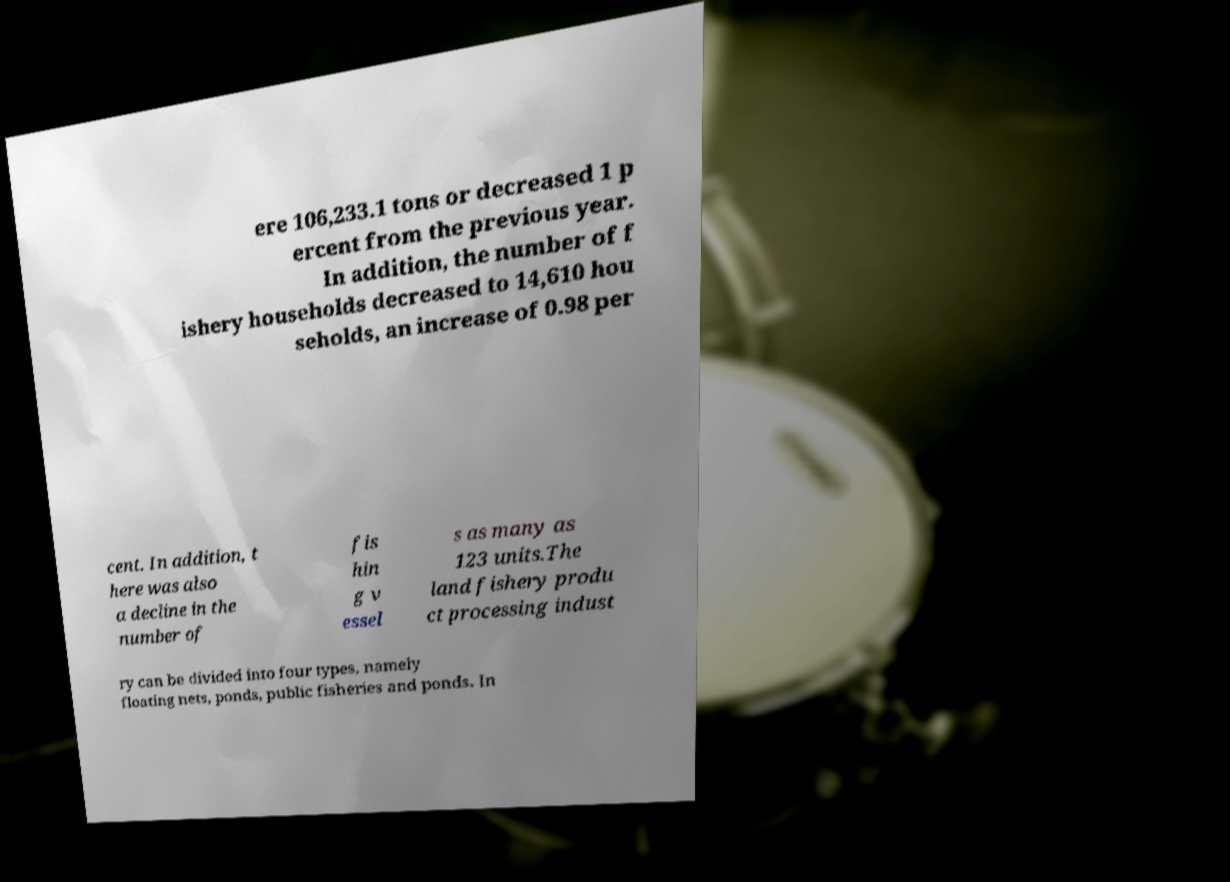I need the written content from this picture converted into text. Can you do that? ere 106,233.1 tons or decreased 1 p ercent from the previous year. In addition, the number of f ishery households decreased to 14,610 hou seholds, an increase of 0.98 per cent. In addition, t here was also a decline in the number of fis hin g v essel s as many as 123 units.The land fishery produ ct processing indust ry can be divided into four types, namely floating nets, ponds, public fisheries and ponds. In 